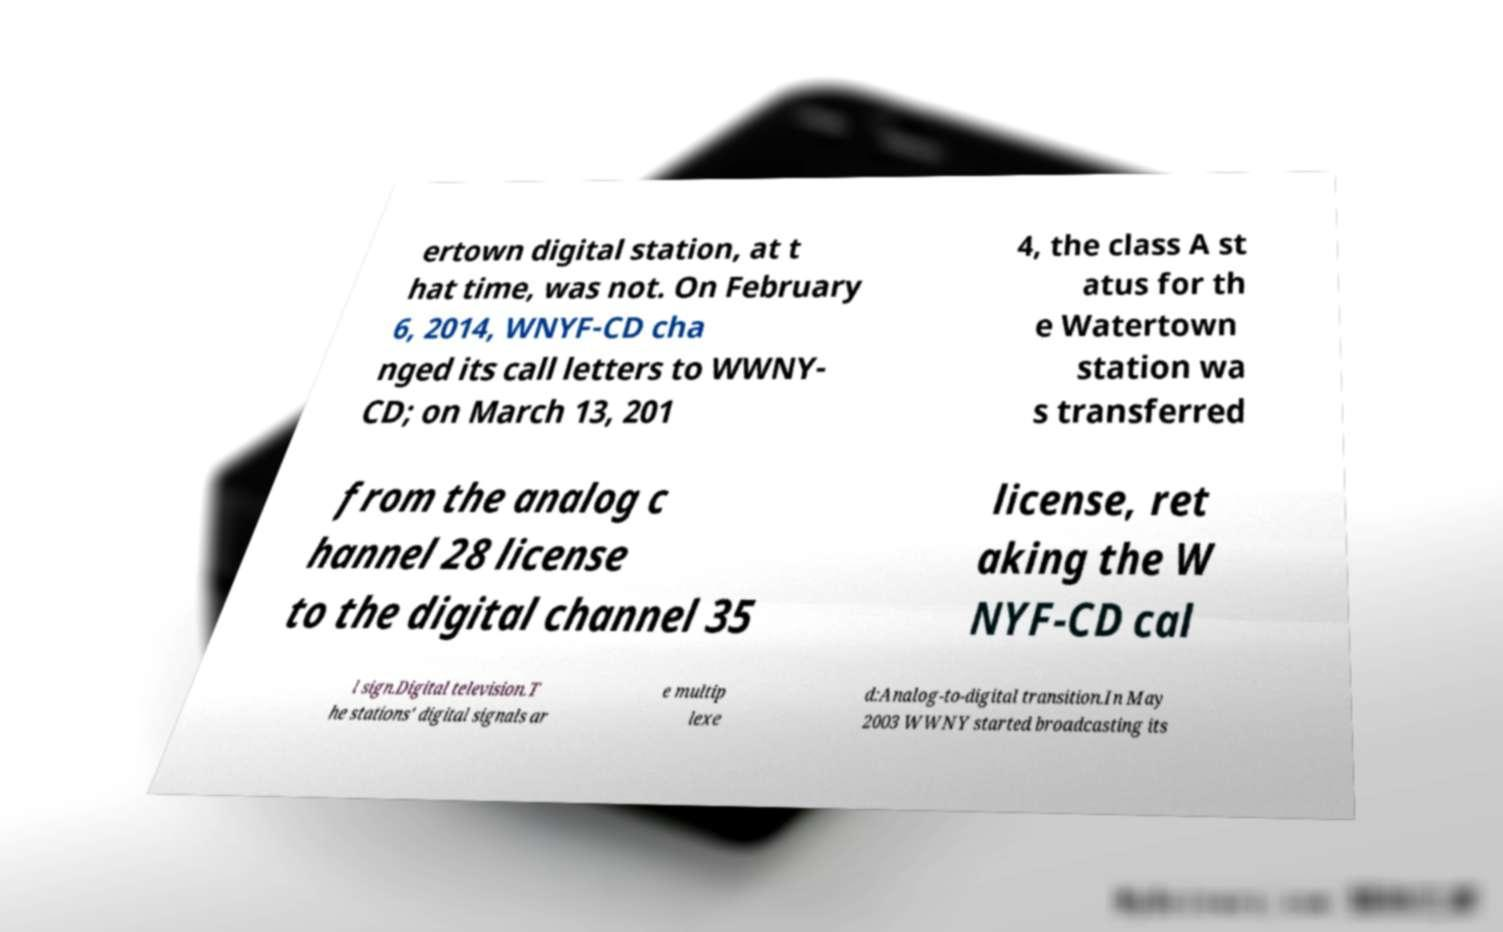Can you read and provide the text displayed in the image?This photo seems to have some interesting text. Can you extract and type it out for me? ertown digital station, at t hat time, was not. On February 6, 2014, WNYF-CD cha nged its call letters to WWNY- CD; on March 13, 201 4, the class A st atus for th e Watertown station wa s transferred from the analog c hannel 28 license to the digital channel 35 license, ret aking the W NYF-CD cal l sign.Digital television.T he stations' digital signals ar e multip lexe d:Analog-to-digital transition.In May 2003 WWNY started broadcasting its 